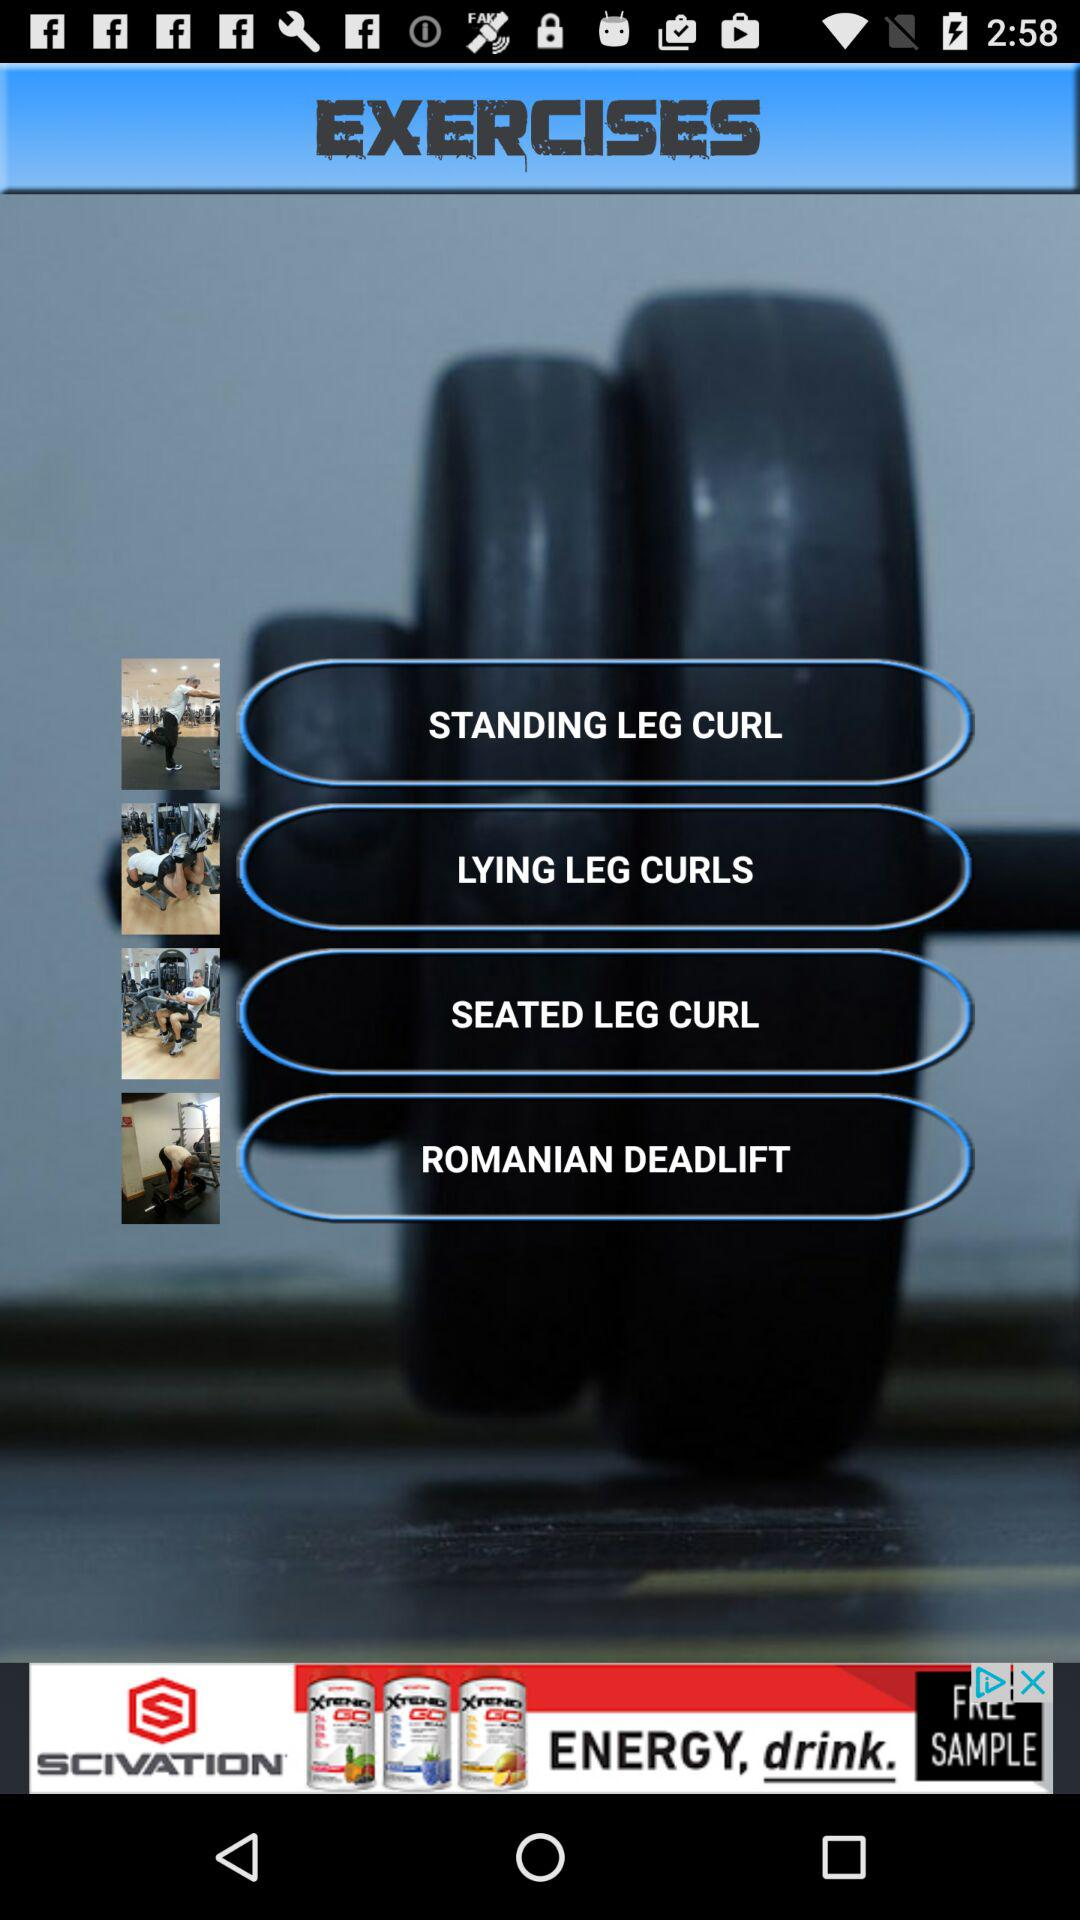How many exercises are there in total?
Answer the question using a single word or phrase. 4 